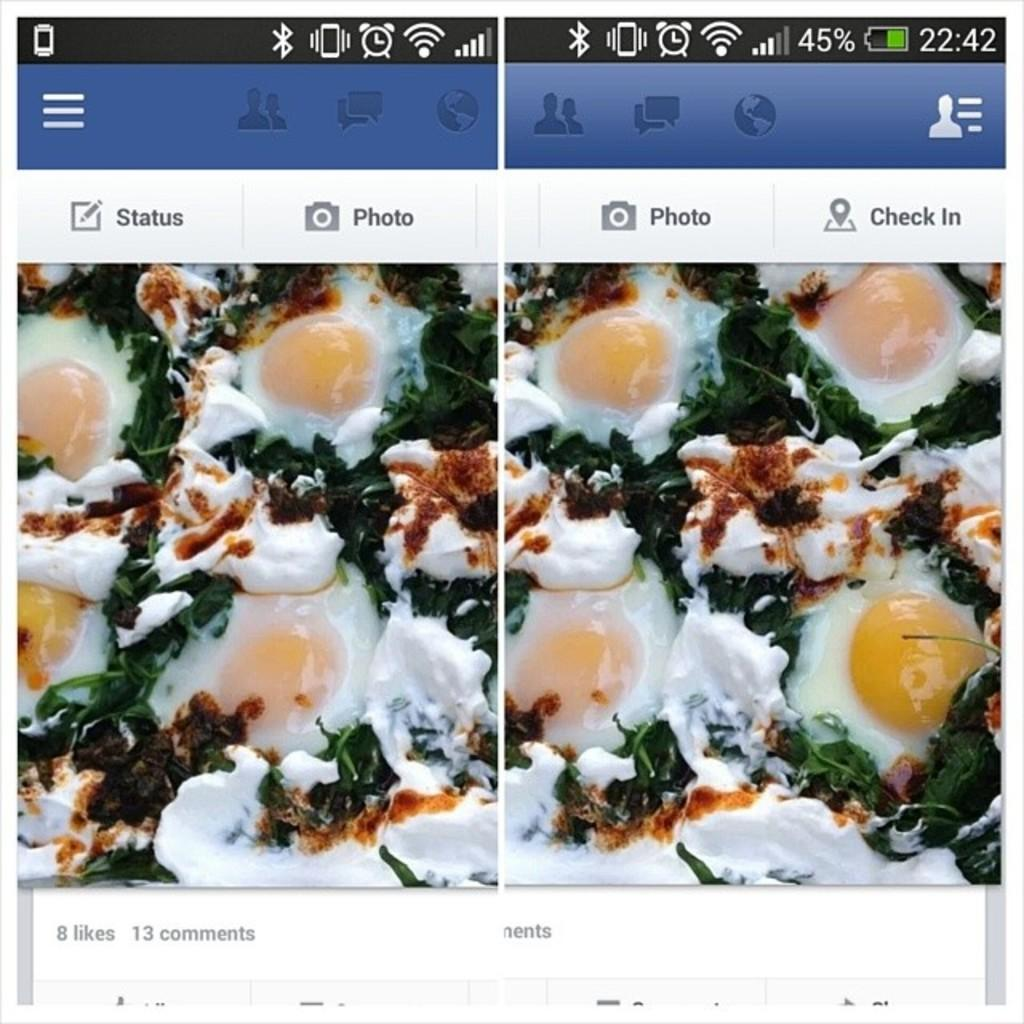What type of image is shown in the screenshot? The image is a screenshot. What can be seen within the screenshot? There are two collage images in the screenshot. How are the collage images related? The collage images are of a similar picture. What type of plant can be seen in the jellyfish collage image? There is no plant or jellyfish present in the image; it contains two collage images of a similar picture. 